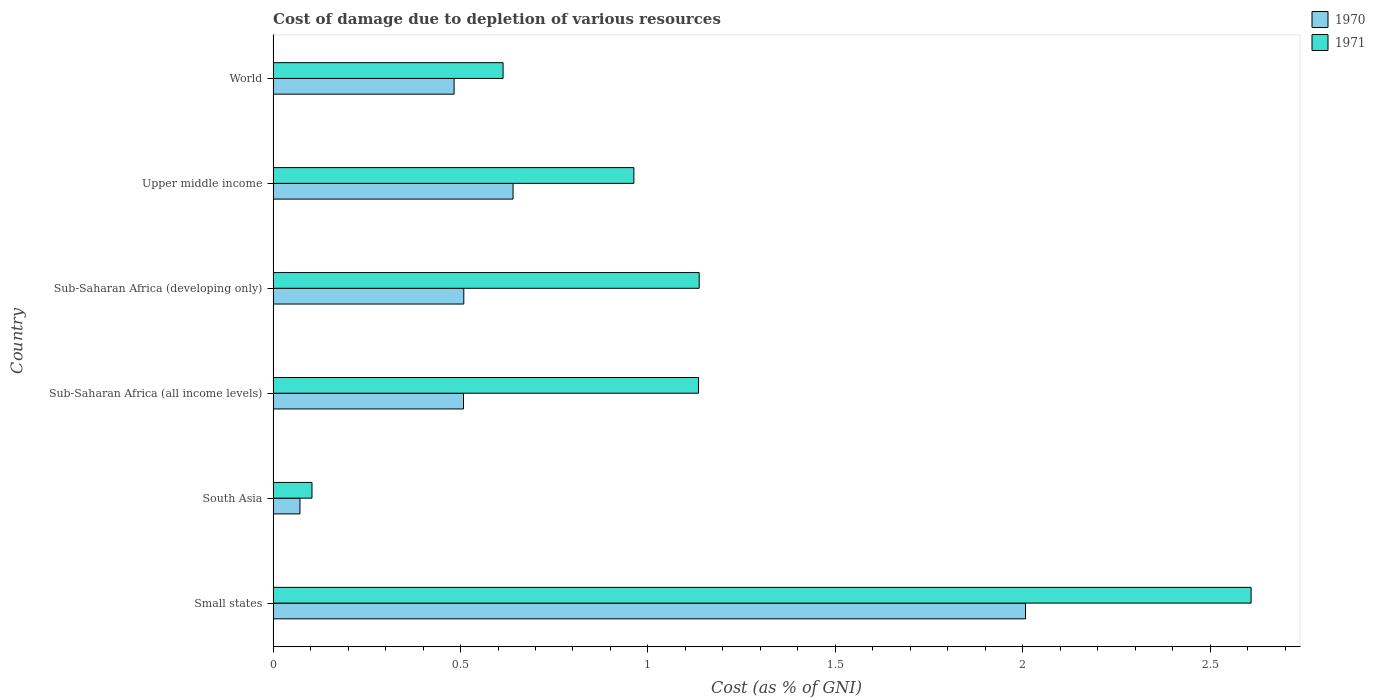How many different coloured bars are there?
Make the answer very short. 2. Are the number of bars per tick equal to the number of legend labels?
Your answer should be compact. Yes. Are the number of bars on each tick of the Y-axis equal?
Your response must be concise. Yes. How many bars are there on the 4th tick from the bottom?
Make the answer very short. 2. What is the label of the 4th group of bars from the top?
Ensure brevity in your answer.  Sub-Saharan Africa (all income levels). What is the cost of damage caused due to the depletion of various resources in 1971 in Upper middle income?
Keep it short and to the point. 0.96. Across all countries, what is the maximum cost of damage caused due to the depletion of various resources in 1971?
Keep it short and to the point. 2.61. Across all countries, what is the minimum cost of damage caused due to the depletion of various resources in 1970?
Give a very brief answer. 0.07. In which country was the cost of damage caused due to the depletion of various resources in 1971 maximum?
Offer a terse response. Small states. In which country was the cost of damage caused due to the depletion of various resources in 1970 minimum?
Your response must be concise. South Asia. What is the total cost of damage caused due to the depletion of various resources in 1970 in the graph?
Offer a terse response. 4.22. What is the difference between the cost of damage caused due to the depletion of various resources in 1971 in Small states and that in Upper middle income?
Offer a terse response. 1.65. What is the difference between the cost of damage caused due to the depletion of various resources in 1971 in Sub-Saharan Africa (all income levels) and the cost of damage caused due to the depletion of various resources in 1970 in Sub-Saharan Africa (developing only)?
Make the answer very short. 0.63. What is the average cost of damage caused due to the depletion of various resources in 1970 per country?
Keep it short and to the point. 0.7. What is the difference between the cost of damage caused due to the depletion of various resources in 1971 and cost of damage caused due to the depletion of various resources in 1970 in Small states?
Keep it short and to the point. 0.6. In how many countries, is the cost of damage caused due to the depletion of various resources in 1970 greater than 0.5 %?
Provide a succinct answer. 4. What is the ratio of the cost of damage caused due to the depletion of various resources in 1970 in Sub-Saharan Africa (all income levels) to that in Sub-Saharan Africa (developing only)?
Make the answer very short. 1. What is the difference between the highest and the second highest cost of damage caused due to the depletion of various resources in 1971?
Your answer should be compact. 1.47. What is the difference between the highest and the lowest cost of damage caused due to the depletion of various resources in 1970?
Keep it short and to the point. 1.94. Is the sum of the cost of damage caused due to the depletion of various resources in 1971 in Sub-Saharan Africa (all income levels) and World greater than the maximum cost of damage caused due to the depletion of various resources in 1970 across all countries?
Offer a very short reply. No. How many bars are there?
Provide a succinct answer. 12. How many countries are there in the graph?
Ensure brevity in your answer.  6. Does the graph contain grids?
Give a very brief answer. No. Where does the legend appear in the graph?
Ensure brevity in your answer.  Top right. What is the title of the graph?
Offer a very short reply. Cost of damage due to depletion of various resources. What is the label or title of the X-axis?
Give a very brief answer. Cost (as % of GNI). What is the Cost (as % of GNI) of 1970 in Small states?
Keep it short and to the point. 2.01. What is the Cost (as % of GNI) in 1971 in Small states?
Provide a short and direct response. 2.61. What is the Cost (as % of GNI) of 1970 in South Asia?
Provide a short and direct response. 0.07. What is the Cost (as % of GNI) in 1971 in South Asia?
Give a very brief answer. 0.1. What is the Cost (as % of GNI) in 1970 in Sub-Saharan Africa (all income levels)?
Offer a very short reply. 0.51. What is the Cost (as % of GNI) of 1971 in Sub-Saharan Africa (all income levels)?
Your answer should be very brief. 1.13. What is the Cost (as % of GNI) in 1970 in Sub-Saharan Africa (developing only)?
Provide a succinct answer. 0.51. What is the Cost (as % of GNI) in 1971 in Sub-Saharan Africa (developing only)?
Ensure brevity in your answer.  1.14. What is the Cost (as % of GNI) in 1970 in Upper middle income?
Offer a terse response. 0.64. What is the Cost (as % of GNI) in 1971 in Upper middle income?
Offer a very short reply. 0.96. What is the Cost (as % of GNI) in 1970 in World?
Provide a succinct answer. 0.48. What is the Cost (as % of GNI) in 1971 in World?
Offer a very short reply. 0.61. Across all countries, what is the maximum Cost (as % of GNI) of 1970?
Offer a very short reply. 2.01. Across all countries, what is the maximum Cost (as % of GNI) in 1971?
Offer a terse response. 2.61. Across all countries, what is the minimum Cost (as % of GNI) in 1970?
Give a very brief answer. 0.07. Across all countries, what is the minimum Cost (as % of GNI) in 1971?
Offer a terse response. 0.1. What is the total Cost (as % of GNI) in 1970 in the graph?
Offer a terse response. 4.22. What is the total Cost (as % of GNI) of 1971 in the graph?
Make the answer very short. 6.56. What is the difference between the Cost (as % of GNI) in 1970 in Small states and that in South Asia?
Your response must be concise. 1.94. What is the difference between the Cost (as % of GNI) in 1971 in Small states and that in South Asia?
Provide a succinct answer. 2.51. What is the difference between the Cost (as % of GNI) of 1970 in Small states and that in Sub-Saharan Africa (all income levels)?
Make the answer very short. 1.5. What is the difference between the Cost (as % of GNI) in 1971 in Small states and that in Sub-Saharan Africa (all income levels)?
Keep it short and to the point. 1.47. What is the difference between the Cost (as % of GNI) of 1970 in Small states and that in Sub-Saharan Africa (developing only)?
Make the answer very short. 1.5. What is the difference between the Cost (as % of GNI) in 1971 in Small states and that in Sub-Saharan Africa (developing only)?
Ensure brevity in your answer.  1.47. What is the difference between the Cost (as % of GNI) of 1970 in Small states and that in Upper middle income?
Make the answer very short. 1.37. What is the difference between the Cost (as % of GNI) of 1971 in Small states and that in Upper middle income?
Offer a terse response. 1.65. What is the difference between the Cost (as % of GNI) in 1970 in Small states and that in World?
Your response must be concise. 1.52. What is the difference between the Cost (as % of GNI) in 1971 in Small states and that in World?
Keep it short and to the point. 2. What is the difference between the Cost (as % of GNI) of 1970 in South Asia and that in Sub-Saharan Africa (all income levels)?
Give a very brief answer. -0.44. What is the difference between the Cost (as % of GNI) of 1971 in South Asia and that in Sub-Saharan Africa (all income levels)?
Provide a short and direct response. -1.03. What is the difference between the Cost (as % of GNI) of 1970 in South Asia and that in Sub-Saharan Africa (developing only)?
Offer a terse response. -0.44. What is the difference between the Cost (as % of GNI) in 1971 in South Asia and that in Sub-Saharan Africa (developing only)?
Offer a very short reply. -1.03. What is the difference between the Cost (as % of GNI) of 1970 in South Asia and that in Upper middle income?
Keep it short and to the point. -0.57. What is the difference between the Cost (as % of GNI) in 1971 in South Asia and that in Upper middle income?
Provide a short and direct response. -0.86. What is the difference between the Cost (as % of GNI) in 1970 in South Asia and that in World?
Your response must be concise. -0.41. What is the difference between the Cost (as % of GNI) of 1971 in South Asia and that in World?
Ensure brevity in your answer.  -0.51. What is the difference between the Cost (as % of GNI) in 1970 in Sub-Saharan Africa (all income levels) and that in Sub-Saharan Africa (developing only)?
Give a very brief answer. -0. What is the difference between the Cost (as % of GNI) of 1971 in Sub-Saharan Africa (all income levels) and that in Sub-Saharan Africa (developing only)?
Your answer should be very brief. -0. What is the difference between the Cost (as % of GNI) in 1970 in Sub-Saharan Africa (all income levels) and that in Upper middle income?
Offer a terse response. -0.13. What is the difference between the Cost (as % of GNI) in 1971 in Sub-Saharan Africa (all income levels) and that in Upper middle income?
Your answer should be very brief. 0.17. What is the difference between the Cost (as % of GNI) in 1970 in Sub-Saharan Africa (all income levels) and that in World?
Give a very brief answer. 0.03. What is the difference between the Cost (as % of GNI) of 1971 in Sub-Saharan Africa (all income levels) and that in World?
Give a very brief answer. 0.52. What is the difference between the Cost (as % of GNI) in 1970 in Sub-Saharan Africa (developing only) and that in Upper middle income?
Provide a short and direct response. -0.13. What is the difference between the Cost (as % of GNI) of 1971 in Sub-Saharan Africa (developing only) and that in Upper middle income?
Your response must be concise. 0.17. What is the difference between the Cost (as % of GNI) in 1970 in Sub-Saharan Africa (developing only) and that in World?
Provide a succinct answer. 0.03. What is the difference between the Cost (as % of GNI) in 1971 in Sub-Saharan Africa (developing only) and that in World?
Offer a terse response. 0.52. What is the difference between the Cost (as % of GNI) in 1970 in Upper middle income and that in World?
Offer a terse response. 0.16. What is the difference between the Cost (as % of GNI) of 1971 in Upper middle income and that in World?
Give a very brief answer. 0.35. What is the difference between the Cost (as % of GNI) of 1970 in Small states and the Cost (as % of GNI) of 1971 in South Asia?
Make the answer very short. 1.9. What is the difference between the Cost (as % of GNI) of 1970 in Small states and the Cost (as % of GNI) of 1971 in Sub-Saharan Africa (all income levels)?
Offer a terse response. 0.87. What is the difference between the Cost (as % of GNI) in 1970 in Small states and the Cost (as % of GNI) in 1971 in Sub-Saharan Africa (developing only)?
Provide a succinct answer. 0.87. What is the difference between the Cost (as % of GNI) in 1970 in Small states and the Cost (as % of GNI) in 1971 in Upper middle income?
Ensure brevity in your answer.  1.04. What is the difference between the Cost (as % of GNI) of 1970 in Small states and the Cost (as % of GNI) of 1971 in World?
Ensure brevity in your answer.  1.39. What is the difference between the Cost (as % of GNI) of 1970 in South Asia and the Cost (as % of GNI) of 1971 in Sub-Saharan Africa (all income levels)?
Give a very brief answer. -1.06. What is the difference between the Cost (as % of GNI) in 1970 in South Asia and the Cost (as % of GNI) in 1971 in Sub-Saharan Africa (developing only)?
Your answer should be compact. -1.07. What is the difference between the Cost (as % of GNI) of 1970 in South Asia and the Cost (as % of GNI) of 1971 in Upper middle income?
Provide a short and direct response. -0.89. What is the difference between the Cost (as % of GNI) of 1970 in South Asia and the Cost (as % of GNI) of 1971 in World?
Provide a succinct answer. -0.54. What is the difference between the Cost (as % of GNI) of 1970 in Sub-Saharan Africa (all income levels) and the Cost (as % of GNI) of 1971 in Sub-Saharan Africa (developing only)?
Ensure brevity in your answer.  -0.63. What is the difference between the Cost (as % of GNI) in 1970 in Sub-Saharan Africa (all income levels) and the Cost (as % of GNI) in 1971 in Upper middle income?
Offer a terse response. -0.45. What is the difference between the Cost (as % of GNI) of 1970 in Sub-Saharan Africa (all income levels) and the Cost (as % of GNI) of 1971 in World?
Provide a succinct answer. -0.11. What is the difference between the Cost (as % of GNI) in 1970 in Sub-Saharan Africa (developing only) and the Cost (as % of GNI) in 1971 in Upper middle income?
Provide a succinct answer. -0.45. What is the difference between the Cost (as % of GNI) of 1970 in Sub-Saharan Africa (developing only) and the Cost (as % of GNI) of 1971 in World?
Ensure brevity in your answer.  -0.1. What is the difference between the Cost (as % of GNI) in 1970 in Upper middle income and the Cost (as % of GNI) in 1971 in World?
Your answer should be compact. 0.03. What is the average Cost (as % of GNI) in 1970 per country?
Give a very brief answer. 0.7. What is the average Cost (as % of GNI) of 1971 per country?
Give a very brief answer. 1.09. What is the difference between the Cost (as % of GNI) of 1970 and Cost (as % of GNI) of 1971 in Small states?
Provide a short and direct response. -0.6. What is the difference between the Cost (as % of GNI) of 1970 and Cost (as % of GNI) of 1971 in South Asia?
Make the answer very short. -0.03. What is the difference between the Cost (as % of GNI) in 1970 and Cost (as % of GNI) in 1971 in Sub-Saharan Africa (all income levels)?
Your answer should be very brief. -0.63. What is the difference between the Cost (as % of GNI) in 1970 and Cost (as % of GNI) in 1971 in Sub-Saharan Africa (developing only)?
Your answer should be very brief. -0.63. What is the difference between the Cost (as % of GNI) in 1970 and Cost (as % of GNI) in 1971 in Upper middle income?
Your response must be concise. -0.32. What is the difference between the Cost (as % of GNI) of 1970 and Cost (as % of GNI) of 1971 in World?
Your answer should be compact. -0.13. What is the ratio of the Cost (as % of GNI) in 1970 in Small states to that in South Asia?
Your answer should be compact. 28.02. What is the ratio of the Cost (as % of GNI) in 1971 in Small states to that in South Asia?
Provide a succinct answer. 25.17. What is the ratio of the Cost (as % of GNI) in 1970 in Small states to that in Sub-Saharan Africa (all income levels)?
Provide a short and direct response. 3.95. What is the ratio of the Cost (as % of GNI) of 1971 in Small states to that in Sub-Saharan Africa (all income levels)?
Your answer should be very brief. 2.3. What is the ratio of the Cost (as % of GNI) of 1970 in Small states to that in Sub-Saharan Africa (developing only)?
Provide a short and direct response. 3.95. What is the ratio of the Cost (as % of GNI) of 1971 in Small states to that in Sub-Saharan Africa (developing only)?
Keep it short and to the point. 2.3. What is the ratio of the Cost (as % of GNI) in 1970 in Small states to that in Upper middle income?
Offer a terse response. 3.14. What is the ratio of the Cost (as % of GNI) in 1971 in Small states to that in Upper middle income?
Provide a succinct answer. 2.71. What is the ratio of the Cost (as % of GNI) in 1970 in Small states to that in World?
Your response must be concise. 4.16. What is the ratio of the Cost (as % of GNI) of 1971 in Small states to that in World?
Your answer should be very brief. 4.25. What is the ratio of the Cost (as % of GNI) of 1970 in South Asia to that in Sub-Saharan Africa (all income levels)?
Your answer should be compact. 0.14. What is the ratio of the Cost (as % of GNI) of 1971 in South Asia to that in Sub-Saharan Africa (all income levels)?
Your response must be concise. 0.09. What is the ratio of the Cost (as % of GNI) in 1970 in South Asia to that in Sub-Saharan Africa (developing only)?
Give a very brief answer. 0.14. What is the ratio of the Cost (as % of GNI) in 1971 in South Asia to that in Sub-Saharan Africa (developing only)?
Keep it short and to the point. 0.09. What is the ratio of the Cost (as % of GNI) in 1970 in South Asia to that in Upper middle income?
Offer a terse response. 0.11. What is the ratio of the Cost (as % of GNI) in 1971 in South Asia to that in Upper middle income?
Your response must be concise. 0.11. What is the ratio of the Cost (as % of GNI) in 1970 in South Asia to that in World?
Provide a succinct answer. 0.15. What is the ratio of the Cost (as % of GNI) in 1971 in South Asia to that in World?
Your answer should be compact. 0.17. What is the ratio of the Cost (as % of GNI) of 1970 in Sub-Saharan Africa (all income levels) to that in Upper middle income?
Your response must be concise. 0.79. What is the ratio of the Cost (as % of GNI) in 1971 in Sub-Saharan Africa (all income levels) to that in Upper middle income?
Keep it short and to the point. 1.18. What is the ratio of the Cost (as % of GNI) of 1970 in Sub-Saharan Africa (all income levels) to that in World?
Your answer should be very brief. 1.05. What is the ratio of the Cost (as % of GNI) of 1971 in Sub-Saharan Africa (all income levels) to that in World?
Your answer should be very brief. 1.85. What is the ratio of the Cost (as % of GNI) of 1970 in Sub-Saharan Africa (developing only) to that in Upper middle income?
Your answer should be compact. 0.79. What is the ratio of the Cost (as % of GNI) in 1971 in Sub-Saharan Africa (developing only) to that in Upper middle income?
Give a very brief answer. 1.18. What is the ratio of the Cost (as % of GNI) in 1970 in Sub-Saharan Africa (developing only) to that in World?
Ensure brevity in your answer.  1.05. What is the ratio of the Cost (as % of GNI) in 1971 in Sub-Saharan Africa (developing only) to that in World?
Offer a very short reply. 1.85. What is the ratio of the Cost (as % of GNI) in 1970 in Upper middle income to that in World?
Ensure brevity in your answer.  1.33. What is the ratio of the Cost (as % of GNI) of 1971 in Upper middle income to that in World?
Provide a succinct answer. 1.57. What is the difference between the highest and the second highest Cost (as % of GNI) in 1970?
Ensure brevity in your answer.  1.37. What is the difference between the highest and the second highest Cost (as % of GNI) of 1971?
Make the answer very short. 1.47. What is the difference between the highest and the lowest Cost (as % of GNI) in 1970?
Give a very brief answer. 1.94. What is the difference between the highest and the lowest Cost (as % of GNI) of 1971?
Your response must be concise. 2.51. 